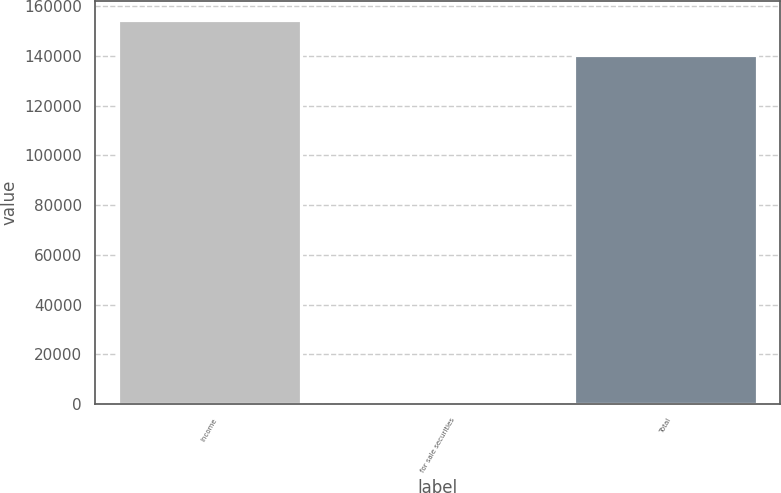Convert chart. <chart><loc_0><loc_0><loc_500><loc_500><bar_chart><fcel>Income<fcel>for sale securities<fcel>Total<nl><fcel>154480<fcel>1358<fcel>140436<nl></chart> 